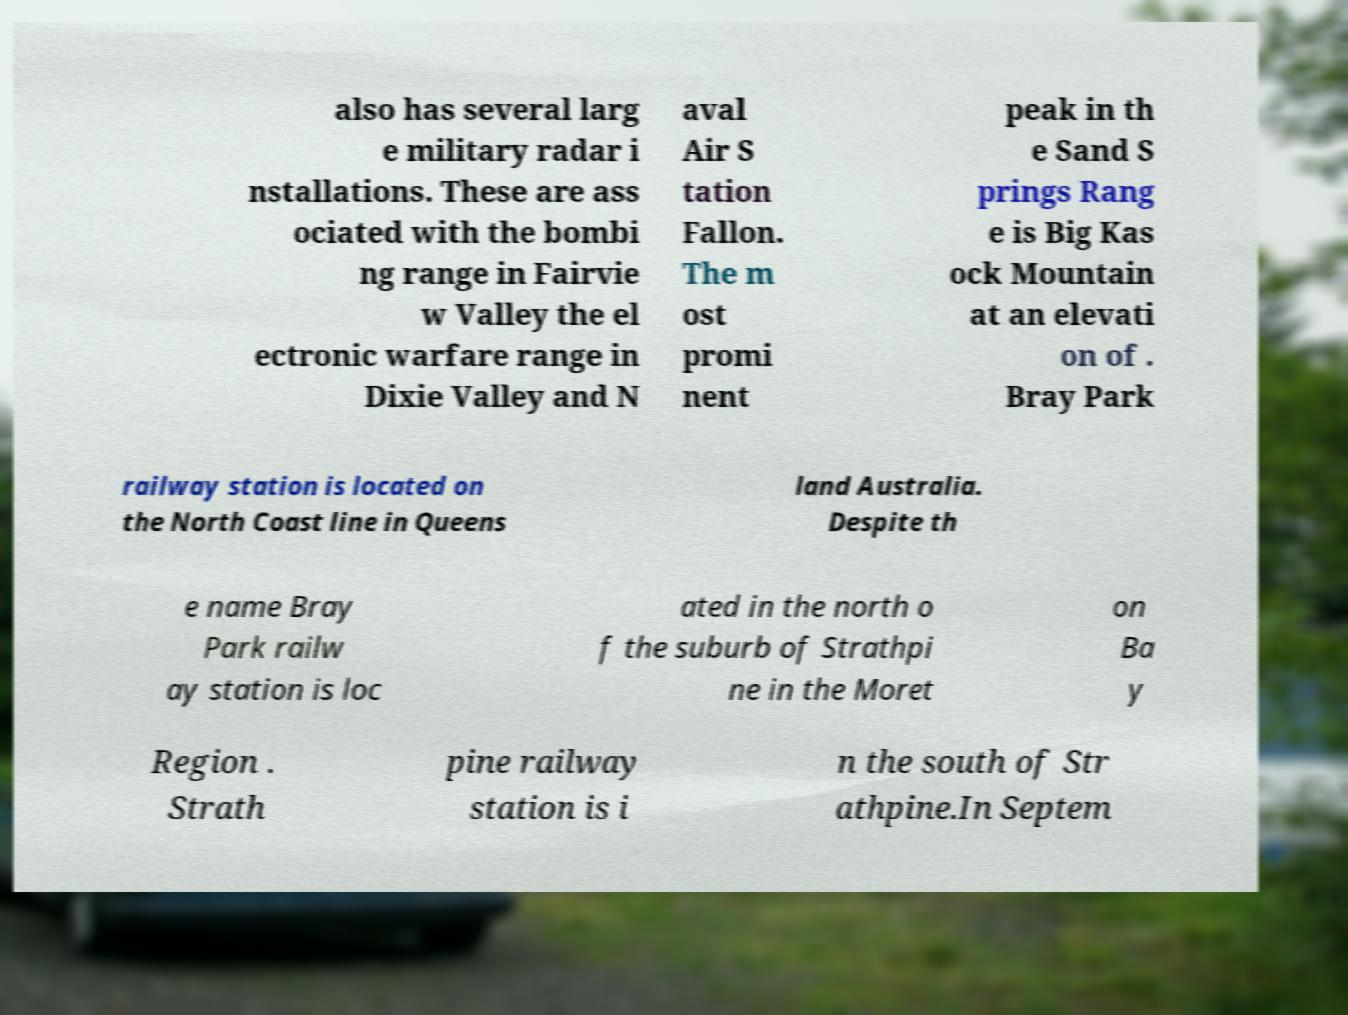For documentation purposes, I need the text within this image transcribed. Could you provide that? also has several larg e military radar i nstallations. These are ass ociated with the bombi ng range in Fairvie w Valley the el ectronic warfare range in Dixie Valley and N aval Air S tation Fallon. The m ost promi nent peak in th e Sand S prings Rang e is Big Kas ock Mountain at an elevati on of . Bray Park railway station is located on the North Coast line in Queens land Australia. Despite th e name Bray Park railw ay station is loc ated in the north o f the suburb of Strathpi ne in the Moret on Ba y Region . Strath pine railway station is i n the south of Str athpine.In Septem 